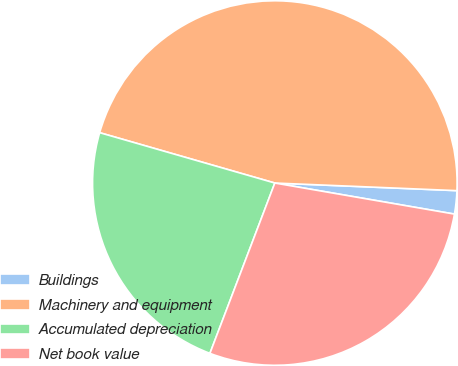Convert chart to OTSL. <chart><loc_0><loc_0><loc_500><loc_500><pie_chart><fcel>Buildings<fcel>Machinery and equipment<fcel>Accumulated depreciation<fcel>Net book value<nl><fcel>2.06%<fcel>46.21%<fcel>23.66%<fcel>28.07%<nl></chart> 